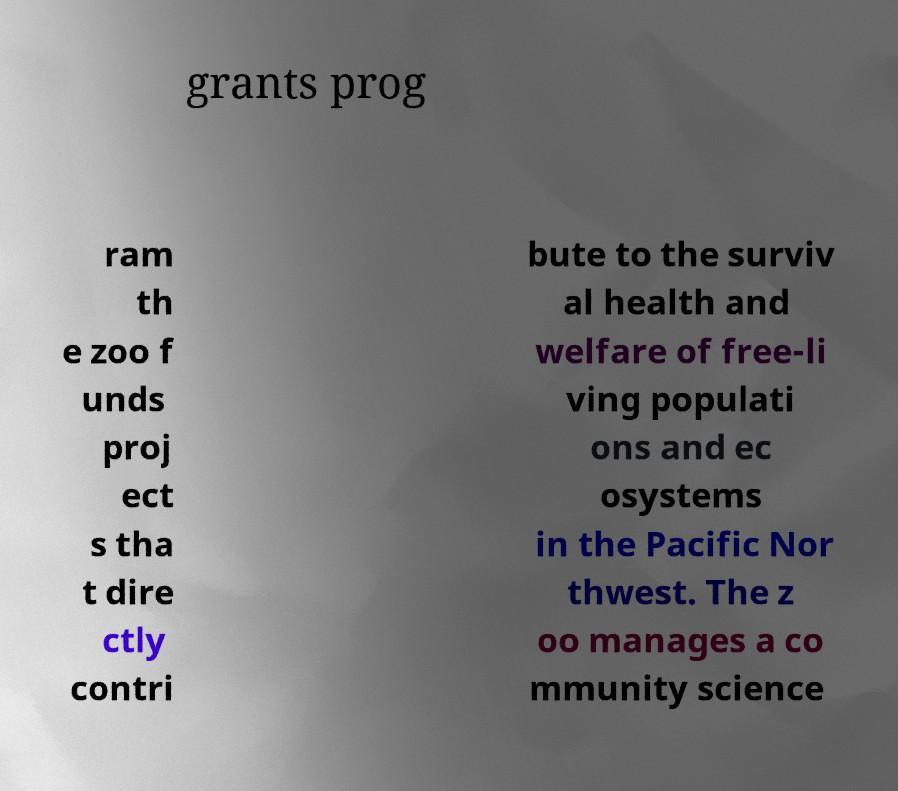What messages or text are displayed in this image? I need them in a readable, typed format. grants prog ram th e zoo f unds proj ect s tha t dire ctly contri bute to the surviv al health and welfare of free-li ving populati ons and ec osystems in the Pacific Nor thwest. The z oo manages a co mmunity science 